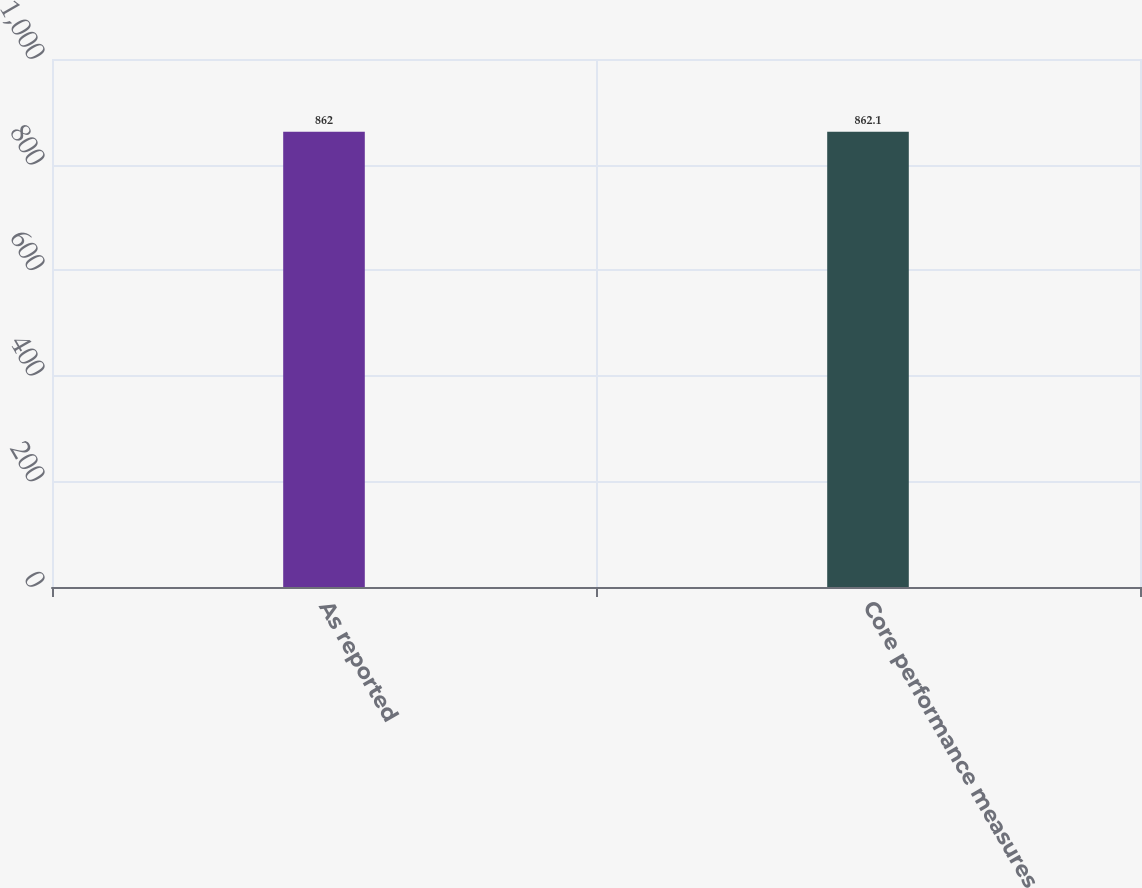<chart> <loc_0><loc_0><loc_500><loc_500><bar_chart><fcel>As reported<fcel>Core performance measures<nl><fcel>862<fcel>862.1<nl></chart> 